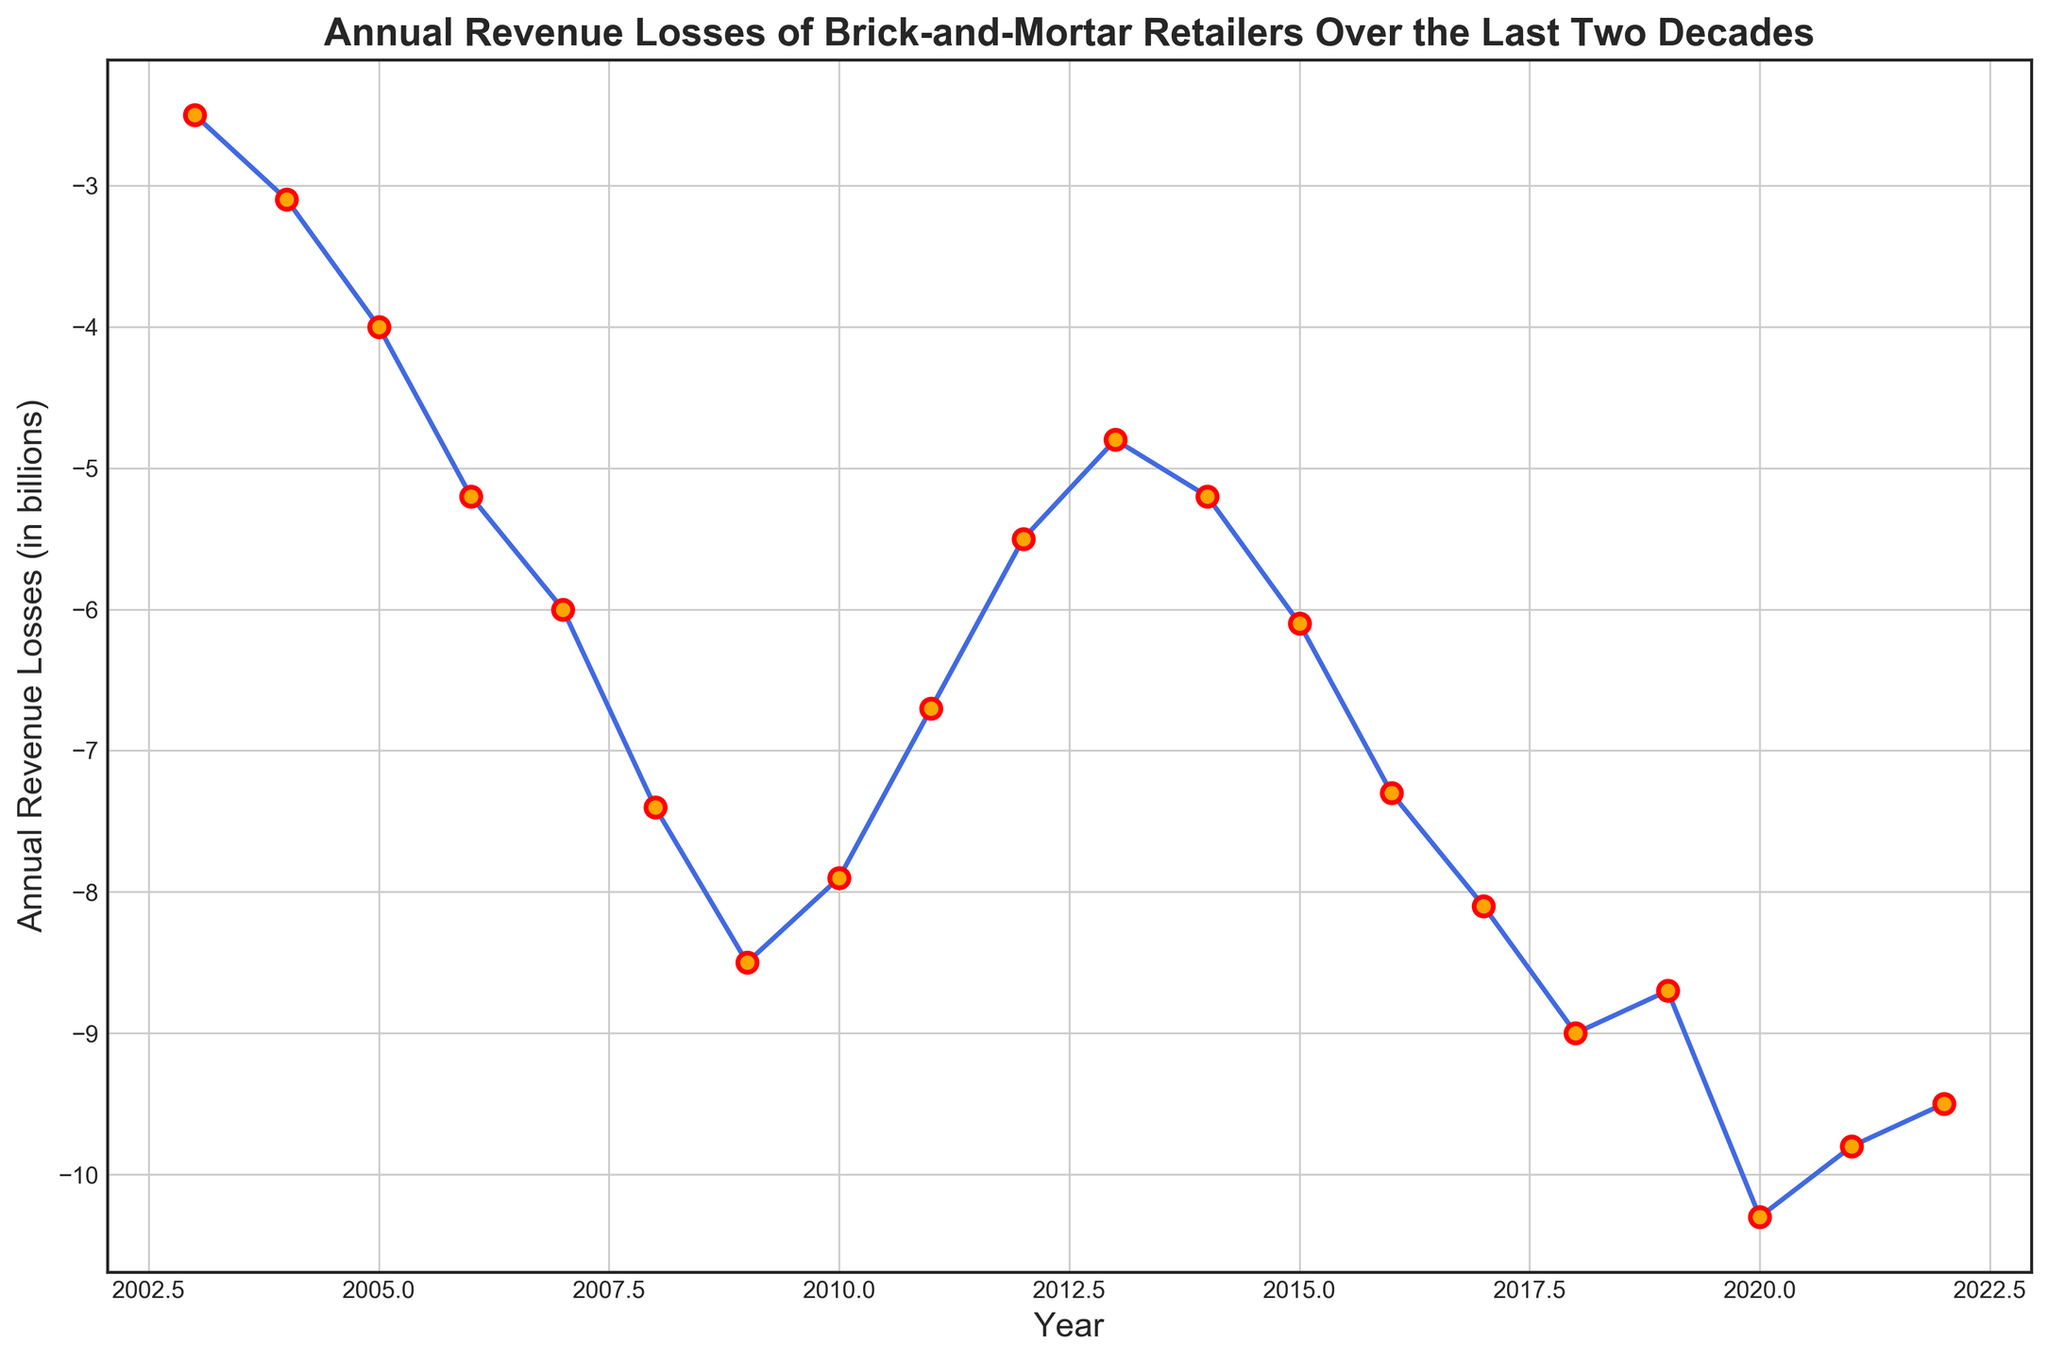What was the annual revenue loss in 2020? Look at the plotted point for the year 2020 on the x-axis, and see the corresponding y-axis value where the point is plotted.
Answer: -10.3 billion In which year did the annual revenue losses first exceed 7 billion dollars? Identify the first year on the x-axis where the plotted value on the y-axis exceeds -7 billion dollars.
Answer: 2008 Which year experienced the lowest annual revenue loss? Observe the plotted points and find the year corresponding to the most negative y-axis value.
Answer: 2020 Between which two consecutive years did the annual revenue losses improve the most? Calculate the difference in annual revenue losses between each pair of consecutive years and identify which pair has the largest positive difference (least negative change).
Answer: 2009 to 2010 What is the overall trend from 2003 to 2022? Observe the general direction of the plotted line from the earliest to the latest year.
Answer: Increasing losses How many years had annual revenue losses greater than or equal to 8 billion dollars? Count the number of years where the plotted points fall below -8 on the y-axis.
Answer: 6 What is the difference in annual revenue losses between 2009 and 2013? Subtract the value of annual revenue losses in 2013 from that in 2009.
Answer: -8.5 - (-4.8) = -3.7 billion Which year had a higher annual revenue loss, 2015 or 2019? Compare the y-axis values for the years 2015 and 2019.
Answer: 2019 What was the approximate average annual revenue loss from 2018 to 2022? Sum the annual revenue losses for the years 2018 to 2022 and divide by the number of years (5).
Answer: (-9.0 + -8.7 + -10.3 + -9.8 + -9.5) / 5 ≈ -9.46 billion Describe the shape of the line between 2011 and 2014. Observe the plotted line's path from 2011 to 2014 to describe its visual direction (e.g., upward, downward, or flat).
Answer: Downward, then upward 